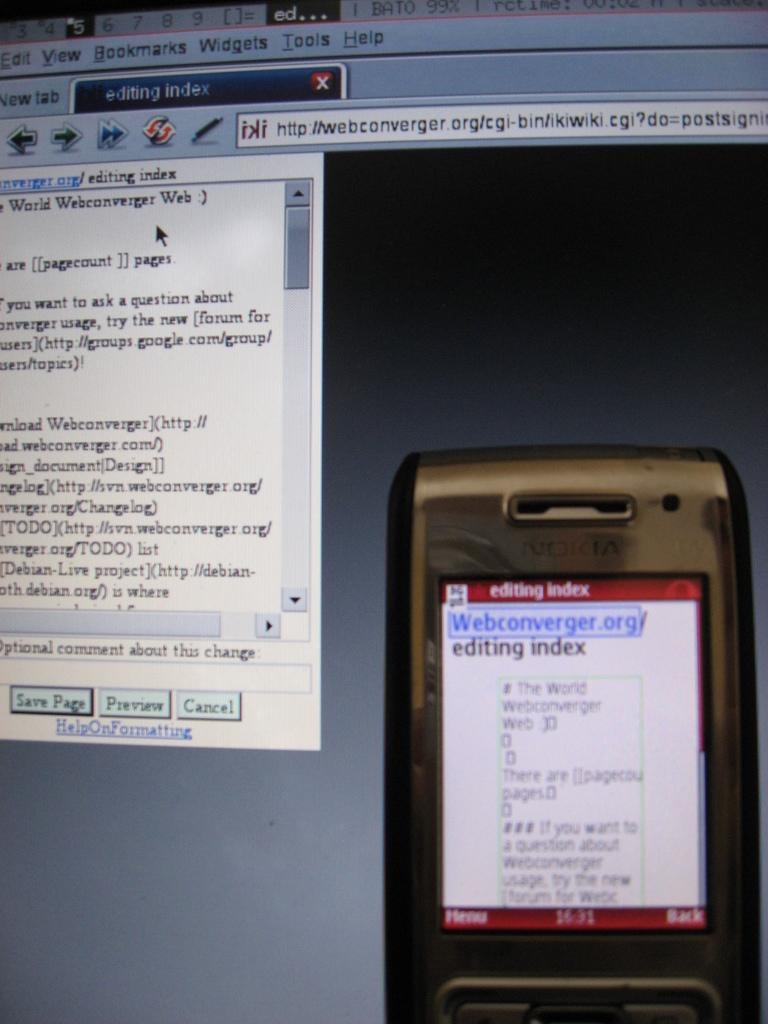<image>
Give a short and clear explanation of the subsequent image. A picture of a camera on a computer screen which has the words editing index on it. 